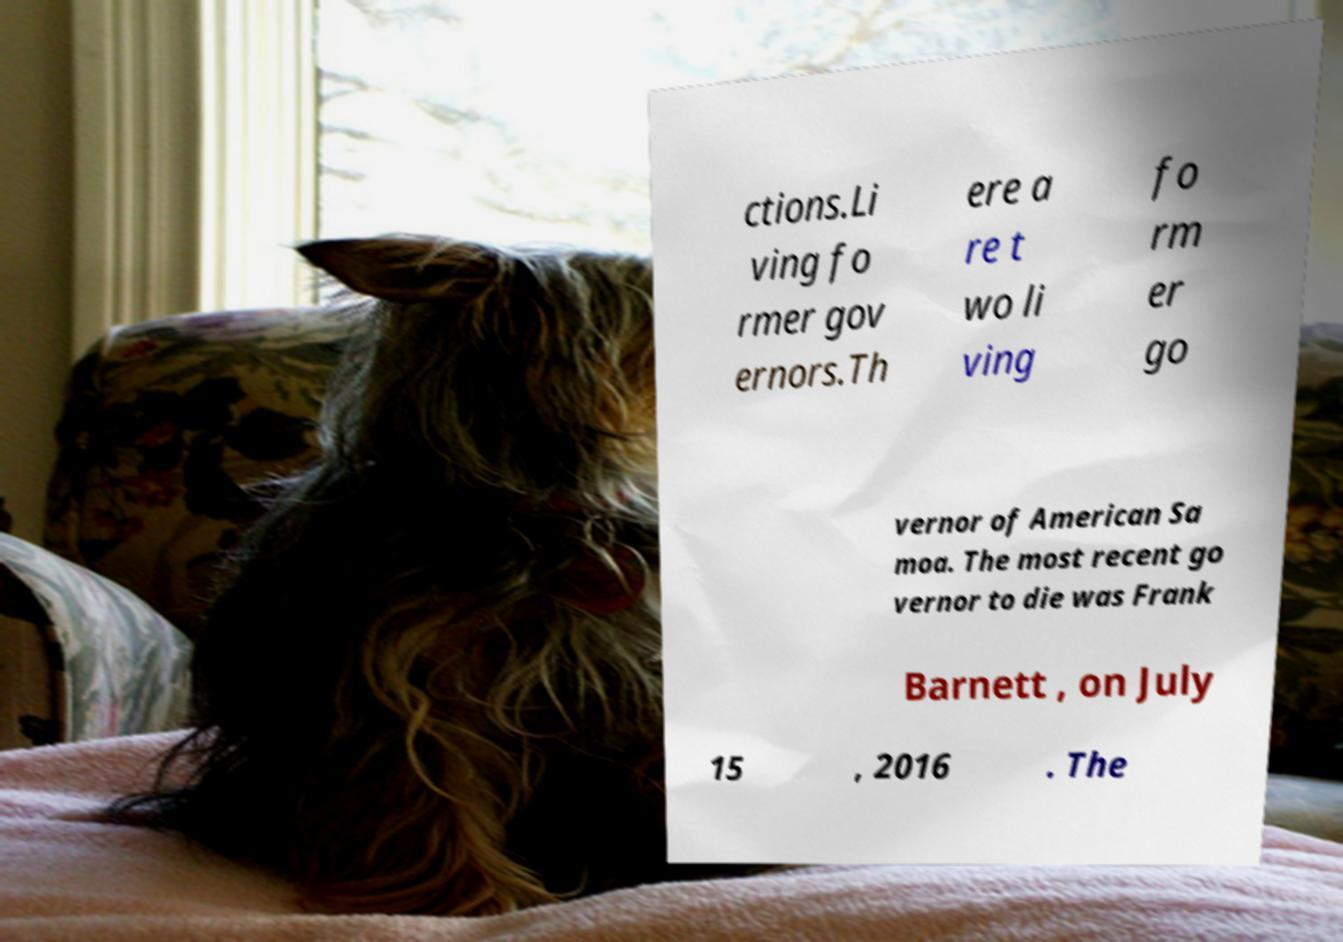Can you read and provide the text displayed in the image?This photo seems to have some interesting text. Can you extract and type it out for me? ctions.Li ving fo rmer gov ernors.Th ere a re t wo li ving fo rm er go vernor of American Sa moa. The most recent go vernor to die was Frank Barnett , on July 15 , 2016 . The 